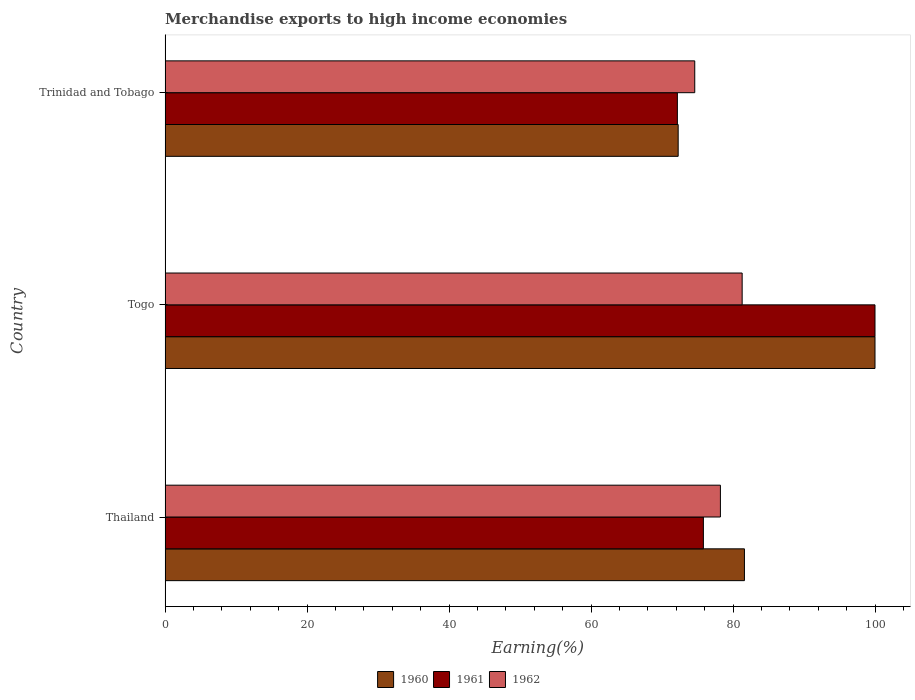How many groups of bars are there?
Provide a short and direct response. 3. Are the number of bars on each tick of the Y-axis equal?
Provide a short and direct response. Yes. How many bars are there on the 2nd tick from the top?
Your response must be concise. 3. How many bars are there on the 2nd tick from the bottom?
Your response must be concise. 3. What is the label of the 3rd group of bars from the top?
Your answer should be very brief. Thailand. What is the percentage of amount earned from merchandise exports in 1961 in Thailand?
Offer a very short reply. 75.83. Across all countries, what is the maximum percentage of amount earned from merchandise exports in 1960?
Offer a very short reply. 100. Across all countries, what is the minimum percentage of amount earned from merchandise exports in 1960?
Give a very brief answer. 72.27. In which country was the percentage of amount earned from merchandise exports in 1960 maximum?
Provide a succinct answer. Togo. In which country was the percentage of amount earned from merchandise exports in 1962 minimum?
Give a very brief answer. Trinidad and Tobago. What is the total percentage of amount earned from merchandise exports in 1962 in the graph?
Your response must be concise. 234.12. What is the difference between the percentage of amount earned from merchandise exports in 1962 in Thailand and that in Togo?
Provide a succinct answer. -3.06. What is the difference between the percentage of amount earned from merchandise exports in 1961 in Thailand and the percentage of amount earned from merchandise exports in 1962 in Togo?
Provide a short and direct response. -5.46. What is the average percentage of amount earned from merchandise exports in 1962 per country?
Ensure brevity in your answer.  78.04. What is the difference between the percentage of amount earned from merchandise exports in 1961 and percentage of amount earned from merchandise exports in 1962 in Trinidad and Tobago?
Give a very brief answer. -2.45. In how many countries, is the percentage of amount earned from merchandise exports in 1962 greater than 84 %?
Provide a short and direct response. 0. What is the ratio of the percentage of amount earned from merchandise exports in 1962 in Thailand to that in Togo?
Provide a succinct answer. 0.96. What is the difference between the highest and the second highest percentage of amount earned from merchandise exports in 1960?
Your answer should be compact. 18.39. What is the difference between the highest and the lowest percentage of amount earned from merchandise exports in 1960?
Your answer should be compact. 27.73. In how many countries, is the percentage of amount earned from merchandise exports in 1962 greater than the average percentage of amount earned from merchandise exports in 1962 taken over all countries?
Keep it short and to the point. 2. Is the sum of the percentage of amount earned from merchandise exports in 1961 in Togo and Trinidad and Tobago greater than the maximum percentage of amount earned from merchandise exports in 1962 across all countries?
Give a very brief answer. Yes. What does the 1st bar from the top in Togo represents?
Your answer should be very brief. 1962. How many bars are there?
Keep it short and to the point. 9. Are all the bars in the graph horizontal?
Give a very brief answer. Yes. Are the values on the major ticks of X-axis written in scientific E-notation?
Provide a short and direct response. No. Does the graph contain any zero values?
Provide a short and direct response. No. Does the graph contain grids?
Give a very brief answer. No. What is the title of the graph?
Ensure brevity in your answer.  Merchandise exports to high income economies. Does "1970" appear as one of the legend labels in the graph?
Provide a succinct answer. No. What is the label or title of the X-axis?
Provide a succinct answer. Earning(%). What is the Earning(%) of 1960 in Thailand?
Ensure brevity in your answer.  81.61. What is the Earning(%) in 1961 in Thailand?
Ensure brevity in your answer.  75.83. What is the Earning(%) of 1962 in Thailand?
Ensure brevity in your answer.  78.22. What is the Earning(%) in 1962 in Togo?
Ensure brevity in your answer.  81.29. What is the Earning(%) in 1960 in Trinidad and Tobago?
Your response must be concise. 72.27. What is the Earning(%) in 1961 in Trinidad and Tobago?
Your response must be concise. 72.16. What is the Earning(%) in 1962 in Trinidad and Tobago?
Your answer should be compact. 74.61. Across all countries, what is the maximum Earning(%) in 1960?
Keep it short and to the point. 100. Across all countries, what is the maximum Earning(%) of 1962?
Your answer should be very brief. 81.29. Across all countries, what is the minimum Earning(%) in 1960?
Offer a very short reply. 72.27. Across all countries, what is the minimum Earning(%) in 1961?
Keep it short and to the point. 72.16. Across all countries, what is the minimum Earning(%) in 1962?
Ensure brevity in your answer.  74.61. What is the total Earning(%) of 1960 in the graph?
Ensure brevity in your answer.  253.88. What is the total Earning(%) of 1961 in the graph?
Keep it short and to the point. 247.99. What is the total Earning(%) of 1962 in the graph?
Give a very brief answer. 234.12. What is the difference between the Earning(%) of 1960 in Thailand and that in Togo?
Keep it short and to the point. -18.39. What is the difference between the Earning(%) in 1961 in Thailand and that in Togo?
Give a very brief answer. -24.17. What is the difference between the Earning(%) of 1962 in Thailand and that in Togo?
Your answer should be very brief. -3.06. What is the difference between the Earning(%) of 1960 in Thailand and that in Trinidad and Tobago?
Your answer should be compact. 9.34. What is the difference between the Earning(%) of 1961 in Thailand and that in Trinidad and Tobago?
Ensure brevity in your answer.  3.66. What is the difference between the Earning(%) of 1962 in Thailand and that in Trinidad and Tobago?
Ensure brevity in your answer.  3.61. What is the difference between the Earning(%) in 1960 in Togo and that in Trinidad and Tobago?
Provide a short and direct response. 27.73. What is the difference between the Earning(%) in 1961 in Togo and that in Trinidad and Tobago?
Give a very brief answer. 27.84. What is the difference between the Earning(%) in 1962 in Togo and that in Trinidad and Tobago?
Keep it short and to the point. 6.68. What is the difference between the Earning(%) of 1960 in Thailand and the Earning(%) of 1961 in Togo?
Your answer should be very brief. -18.39. What is the difference between the Earning(%) in 1960 in Thailand and the Earning(%) in 1962 in Togo?
Offer a terse response. 0.32. What is the difference between the Earning(%) in 1961 in Thailand and the Earning(%) in 1962 in Togo?
Provide a short and direct response. -5.46. What is the difference between the Earning(%) of 1960 in Thailand and the Earning(%) of 1961 in Trinidad and Tobago?
Your answer should be very brief. 9.45. What is the difference between the Earning(%) of 1960 in Thailand and the Earning(%) of 1962 in Trinidad and Tobago?
Ensure brevity in your answer.  7. What is the difference between the Earning(%) in 1961 in Thailand and the Earning(%) in 1962 in Trinidad and Tobago?
Ensure brevity in your answer.  1.22. What is the difference between the Earning(%) in 1960 in Togo and the Earning(%) in 1961 in Trinidad and Tobago?
Keep it short and to the point. 27.84. What is the difference between the Earning(%) of 1960 in Togo and the Earning(%) of 1962 in Trinidad and Tobago?
Your answer should be very brief. 25.39. What is the difference between the Earning(%) in 1961 in Togo and the Earning(%) in 1962 in Trinidad and Tobago?
Make the answer very short. 25.39. What is the average Earning(%) in 1960 per country?
Provide a succinct answer. 84.63. What is the average Earning(%) of 1961 per country?
Make the answer very short. 82.66. What is the average Earning(%) in 1962 per country?
Your answer should be compact. 78.04. What is the difference between the Earning(%) in 1960 and Earning(%) in 1961 in Thailand?
Your answer should be compact. 5.78. What is the difference between the Earning(%) in 1960 and Earning(%) in 1962 in Thailand?
Offer a terse response. 3.39. What is the difference between the Earning(%) of 1961 and Earning(%) of 1962 in Thailand?
Offer a terse response. -2.4. What is the difference between the Earning(%) in 1960 and Earning(%) in 1961 in Togo?
Ensure brevity in your answer.  0. What is the difference between the Earning(%) of 1960 and Earning(%) of 1962 in Togo?
Your answer should be very brief. 18.71. What is the difference between the Earning(%) in 1961 and Earning(%) in 1962 in Togo?
Keep it short and to the point. 18.71. What is the difference between the Earning(%) of 1960 and Earning(%) of 1961 in Trinidad and Tobago?
Give a very brief answer. 0.11. What is the difference between the Earning(%) in 1960 and Earning(%) in 1962 in Trinidad and Tobago?
Your answer should be very brief. -2.34. What is the difference between the Earning(%) of 1961 and Earning(%) of 1962 in Trinidad and Tobago?
Your response must be concise. -2.45. What is the ratio of the Earning(%) in 1960 in Thailand to that in Togo?
Make the answer very short. 0.82. What is the ratio of the Earning(%) of 1961 in Thailand to that in Togo?
Provide a short and direct response. 0.76. What is the ratio of the Earning(%) in 1962 in Thailand to that in Togo?
Offer a very short reply. 0.96. What is the ratio of the Earning(%) in 1960 in Thailand to that in Trinidad and Tobago?
Your answer should be compact. 1.13. What is the ratio of the Earning(%) of 1961 in Thailand to that in Trinidad and Tobago?
Offer a terse response. 1.05. What is the ratio of the Earning(%) of 1962 in Thailand to that in Trinidad and Tobago?
Give a very brief answer. 1.05. What is the ratio of the Earning(%) in 1960 in Togo to that in Trinidad and Tobago?
Offer a very short reply. 1.38. What is the ratio of the Earning(%) of 1961 in Togo to that in Trinidad and Tobago?
Provide a short and direct response. 1.39. What is the ratio of the Earning(%) of 1962 in Togo to that in Trinidad and Tobago?
Your response must be concise. 1.09. What is the difference between the highest and the second highest Earning(%) of 1960?
Ensure brevity in your answer.  18.39. What is the difference between the highest and the second highest Earning(%) of 1961?
Your answer should be very brief. 24.17. What is the difference between the highest and the second highest Earning(%) of 1962?
Your response must be concise. 3.06. What is the difference between the highest and the lowest Earning(%) in 1960?
Offer a terse response. 27.73. What is the difference between the highest and the lowest Earning(%) in 1961?
Your answer should be compact. 27.84. What is the difference between the highest and the lowest Earning(%) in 1962?
Ensure brevity in your answer.  6.68. 